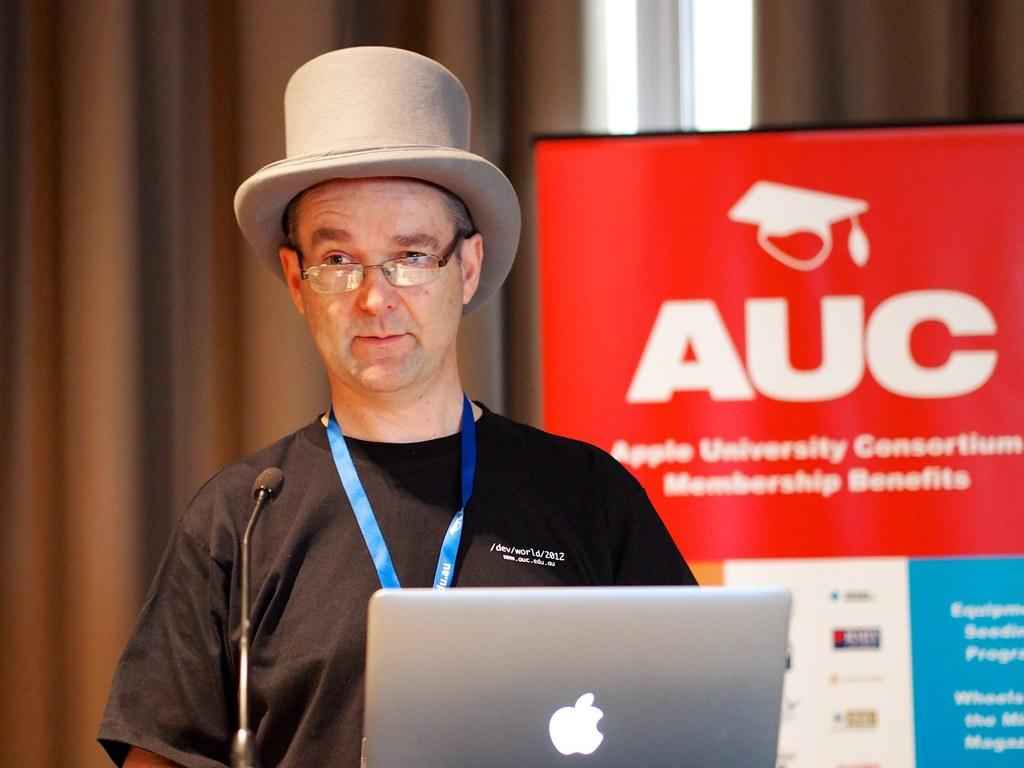Who is present in the image? There is a man in the image. What is the man wearing on his head? The man is wearing a cap. What is the man wearing on his face? The man is wearing spectacles. What is in front of the man? There is a microphone and a laptop in front of the man. What can be seen in the background of the image? There is a hoarding in the background of the image. What color is the crayon the man is holding in the image? There is no crayon present in the image; the man is not holding any crayons. What type of dress is the man wearing in the image? The man is not wearing a dress in the image; he is wearing a cap and spectacles. 